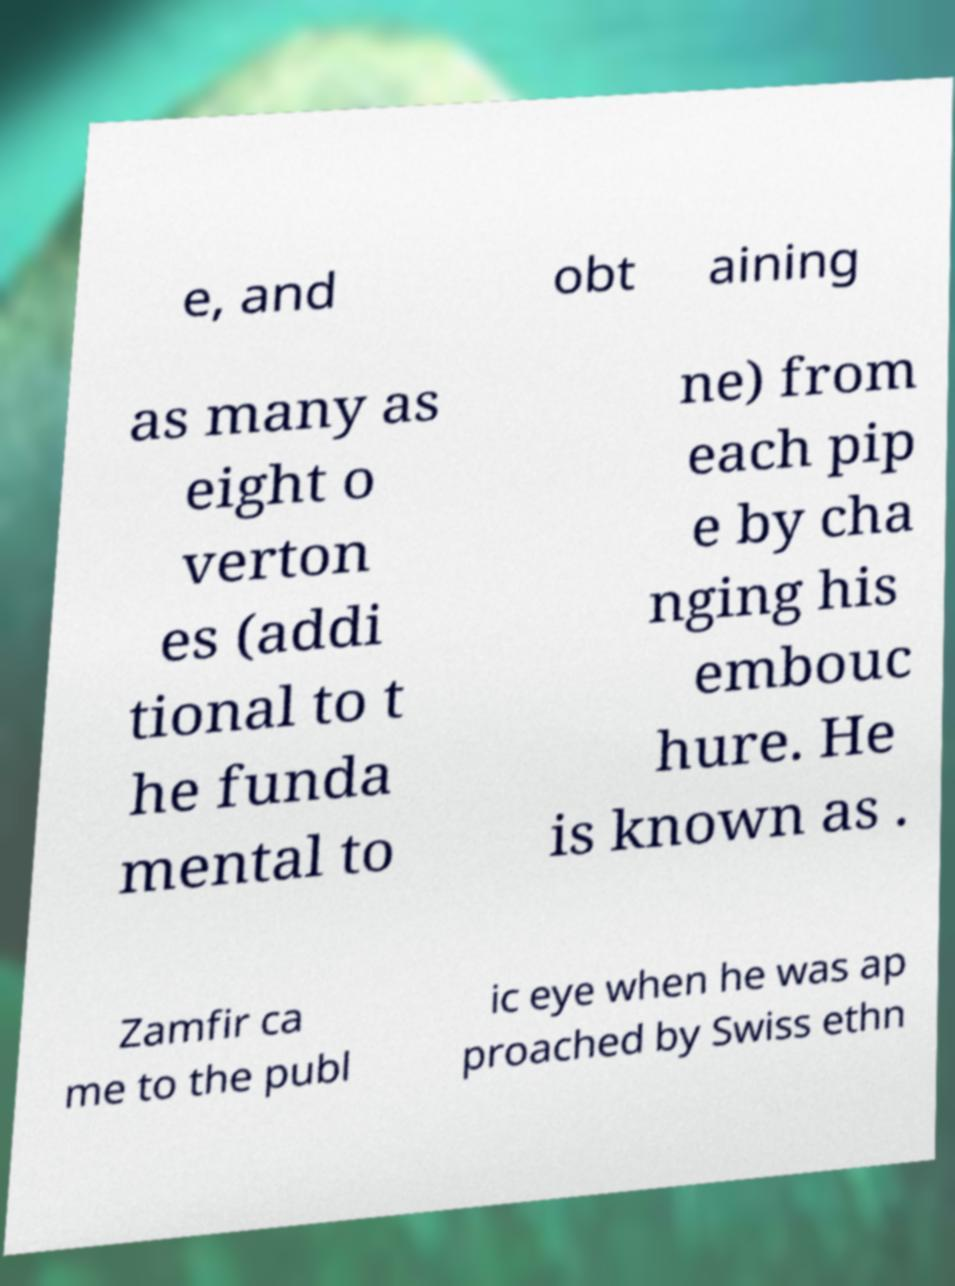Please read and relay the text visible in this image. What does it say? e, and obt aining as many as eight o verton es (addi tional to t he funda mental to ne) from each pip e by cha nging his embouc hure. He is known as . Zamfir ca me to the publ ic eye when he was ap proached by Swiss ethn 